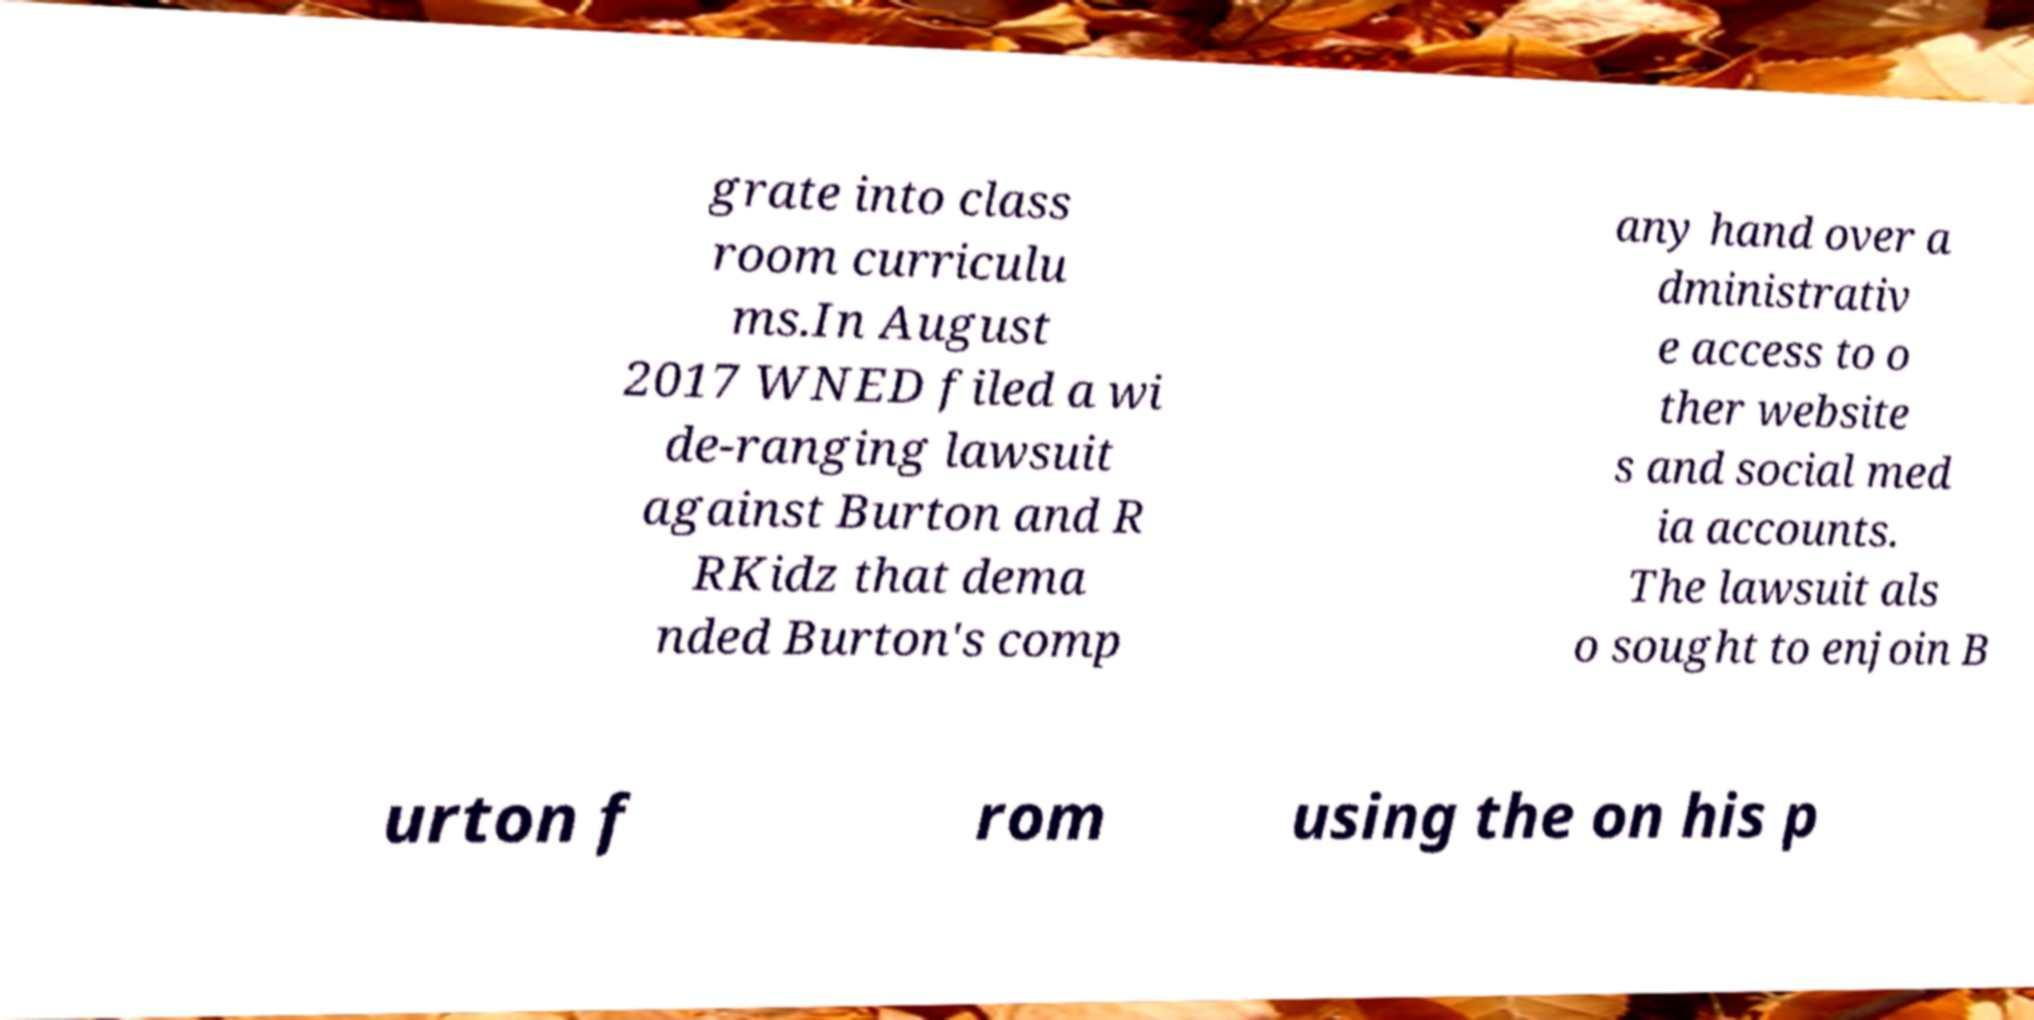What messages or text are displayed in this image? I need them in a readable, typed format. grate into class room curriculu ms.In August 2017 WNED filed a wi de-ranging lawsuit against Burton and R RKidz that dema nded Burton's comp any hand over a dministrativ e access to o ther website s and social med ia accounts. The lawsuit als o sought to enjoin B urton f rom using the on his p 